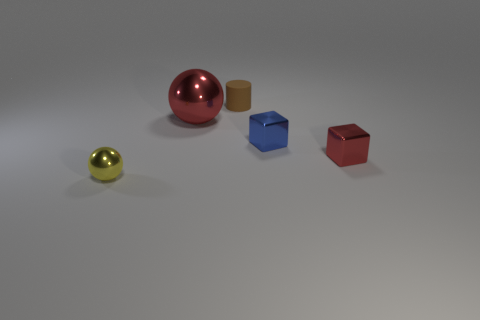What number of tiny metallic cubes are the same color as the large metal ball?
Provide a short and direct response. 1. How many other cubes have the same material as the red block?
Offer a very short reply. 1. Does the cube that is behind the red cube have the same size as the matte cylinder?
Offer a very short reply. Yes. There is a rubber thing that is the same size as the yellow metallic object; what color is it?
Your answer should be very brief. Brown. There is a tiny yellow shiny thing; how many small shiny spheres are on the left side of it?
Offer a terse response. 0. Is there a tiny yellow cylinder?
Your answer should be very brief. No. What size is the red thing that is to the right of the tiny thing that is behind the metallic ball that is behind the small red cube?
Give a very brief answer. Small. What number of other things are there of the same size as the blue shiny block?
Ensure brevity in your answer.  3. There is a shiny sphere right of the yellow shiny sphere; how big is it?
Provide a succinct answer. Large. Is there any other thing that is the same color as the matte cylinder?
Your answer should be very brief. No. 